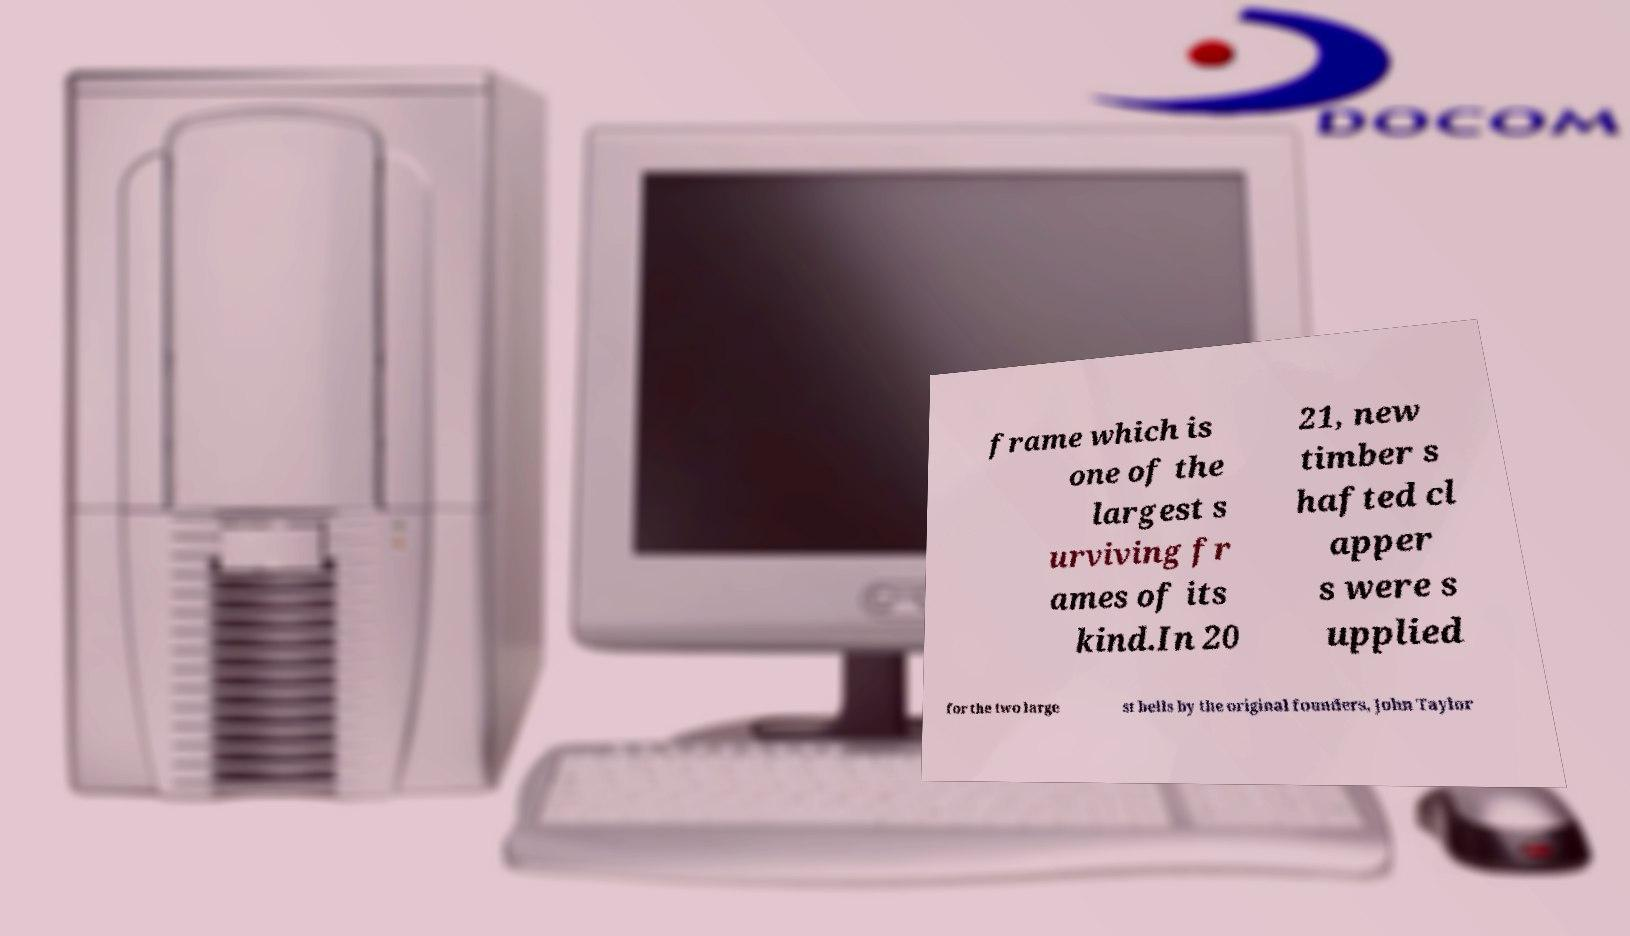Could you extract and type out the text from this image? frame which is one of the largest s urviving fr ames of its kind.In 20 21, new timber s hafted cl apper s were s upplied for the two large st bells by the original founders, John Taylor 